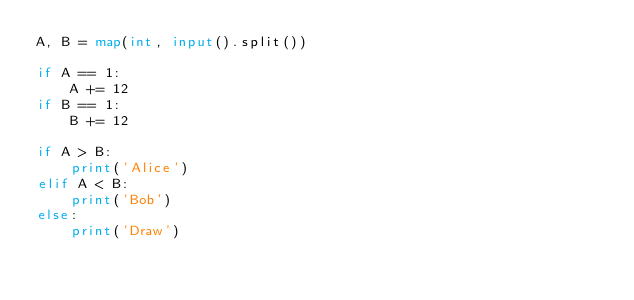Convert code to text. <code><loc_0><loc_0><loc_500><loc_500><_Python_>A, B = map(int, input().split())

if A == 1:
    A += 12
if B == 1:
    B += 12

if A > B:
    print('Alice')
elif A < B:
    print('Bob')
else:
    print('Draw')</code> 